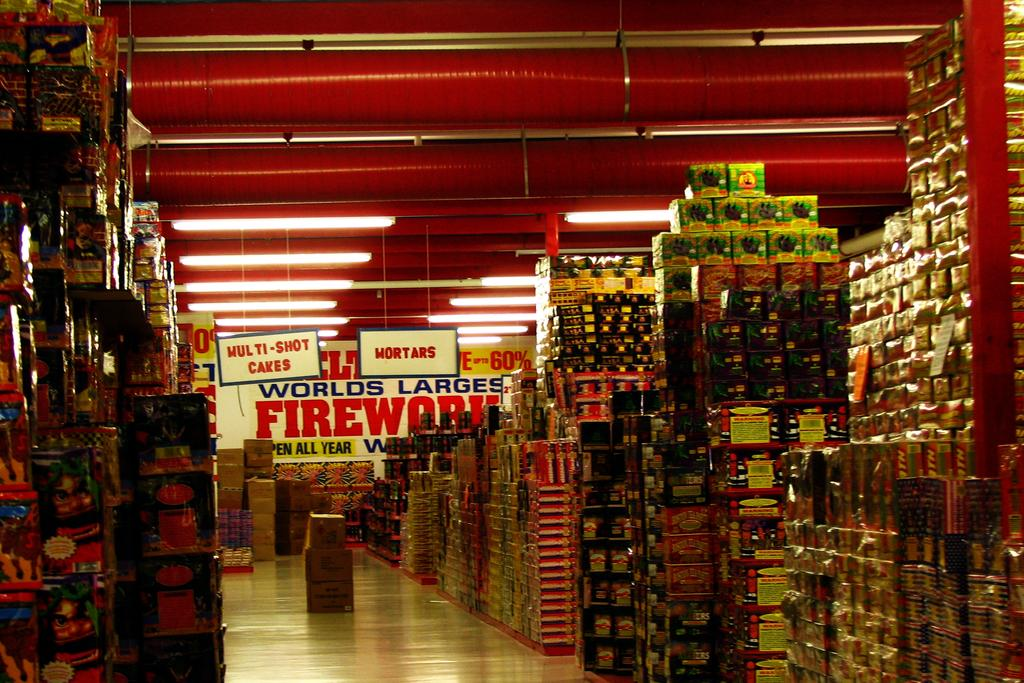<image>
Summarize the visual content of the image. Store that contains the worlds largest firework and shot cakes 